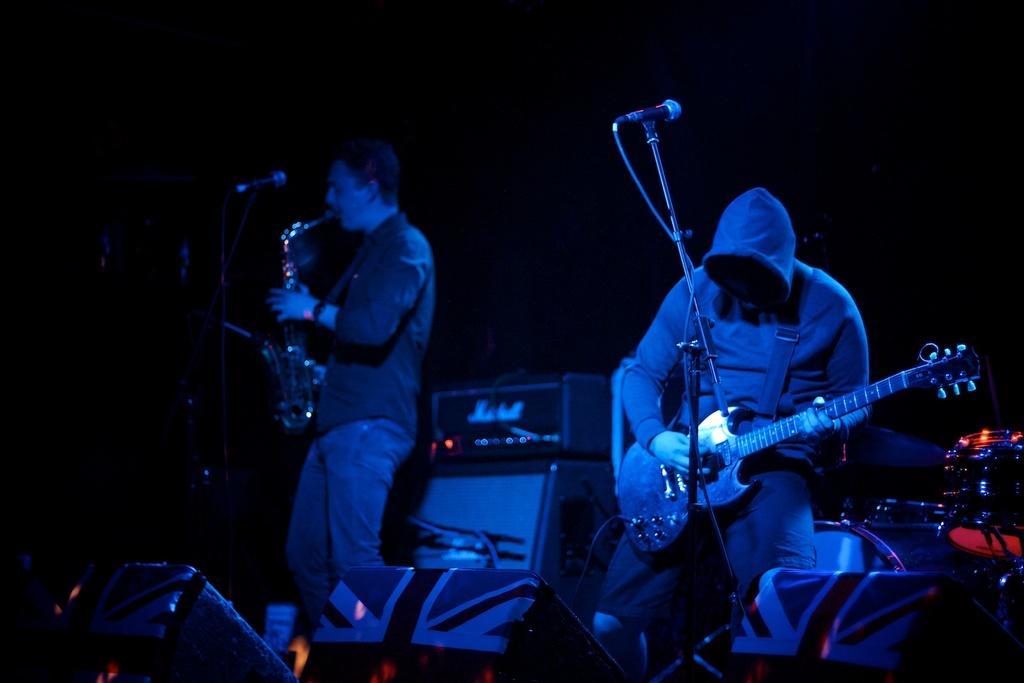Can you describe this image briefly? In this picture I can see two persons standing. I can see a person holding a guitar and there is another person holding a saxophone. I can see speakers, mics with the miles stands, drums and some other objects, and there is dark background. 